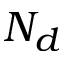<formula> <loc_0><loc_0><loc_500><loc_500>N _ { d }</formula> 